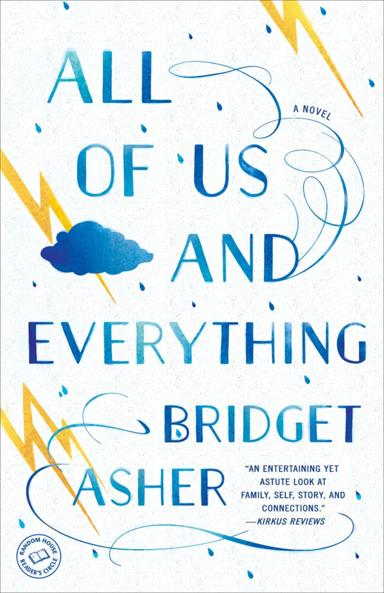Can you describe an intriguing character from the novel portrayed in the image? One of the central characters is Esme, whose charismatic yet enigmatic persona drives much of the novel's storyline. She delves into self-discovery after decades of secrets and surprises, providing a rich narrative about personal growth and understanding. 